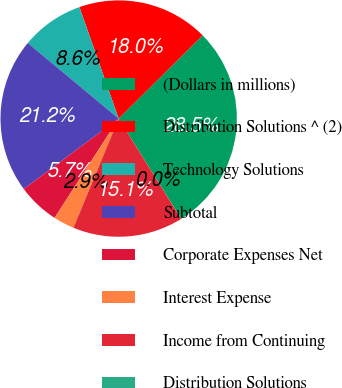<chart> <loc_0><loc_0><loc_500><loc_500><pie_chart><fcel>(Dollars in millions)<fcel>Distribution Solutions ^ (2)<fcel>Technology Solutions<fcel>Subtotal<fcel>Corporate Expenses Net<fcel>Interest Expense<fcel>Income from Continuing<fcel>Distribution Solutions<nl><fcel>28.54%<fcel>17.97%<fcel>8.57%<fcel>21.2%<fcel>5.72%<fcel>2.87%<fcel>15.12%<fcel>0.02%<nl></chart> 